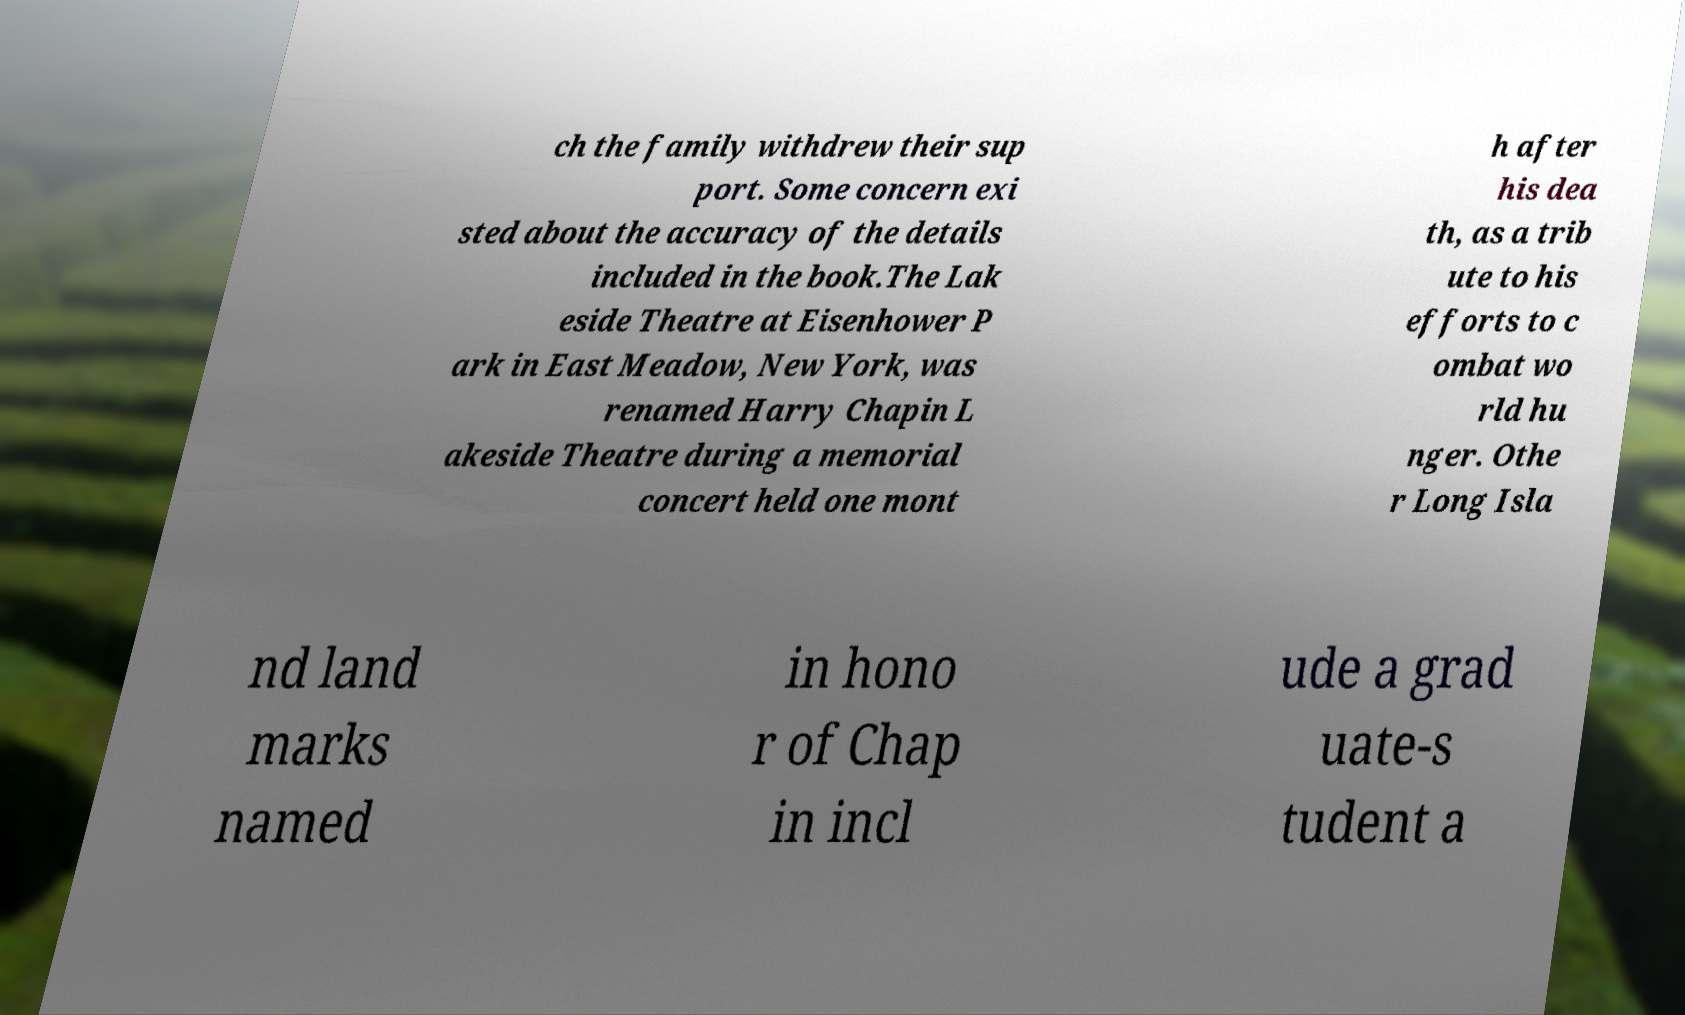Could you assist in decoding the text presented in this image and type it out clearly? ch the family withdrew their sup port. Some concern exi sted about the accuracy of the details included in the book.The Lak eside Theatre at Eisenhower P ark in East Meadow, New York, was renamed Harry Chapin L akeside Theatre during a memorial concert held one mont h after his dea th, as a trib ute to his efforts to c ombat wo rld hu nger. Othe r Long Isla nd land marks named in hono r of Chap in incl ude a grad uate-s tudent a 